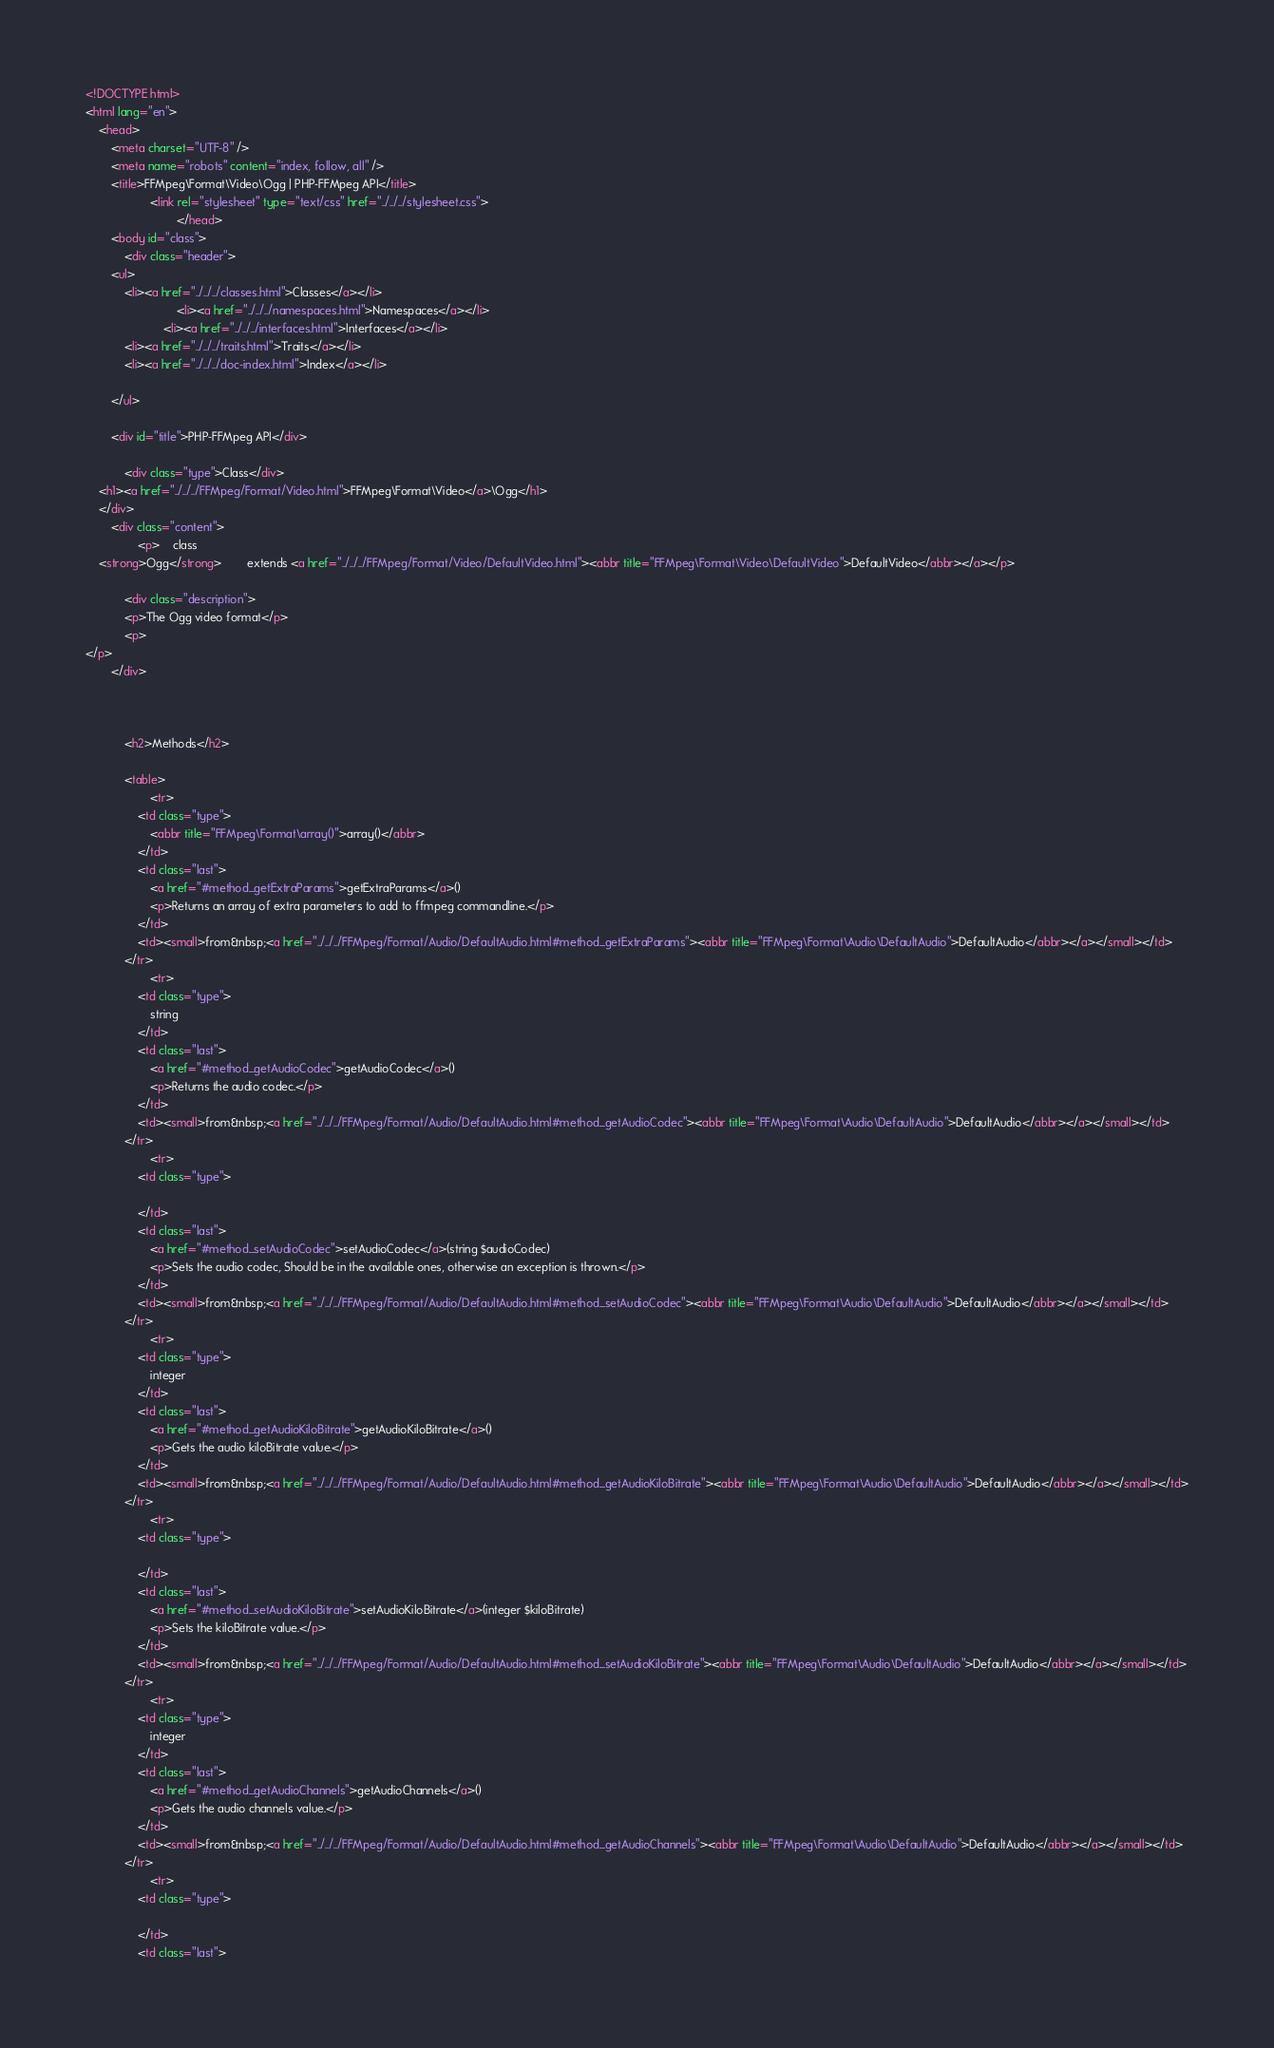Convert code to text. <code><loc_0><loc_0><loc_500><loc_500><_HTML_><!DOCTYPE html>
<html lang="en">
    <head>
        <meta charset="UTF-8" />
        <meta name="robots" content="index, follow, all" />
        <title>FFMpeg\Format\Video\Ogg | PHP-FFMpeg API</title>
                    <link rel="stylesheet" type="text/css" href="../../../stylesheet.css">
                            </head>
        <body id="class">
            <div class="header">
        <ul>
            <li><a href="../../../classes.html">Classes</a></li>
                            <li><a href="../../../namespaces.html">Namespaces</a></li>
                        <li><a href="../../../interfaces.html">Interfaces</a></li>
            <li><a href="../../../traits.html">Traits</a></li>
            <li><a href="../../../doc-index.html">Index</a></li>
            
        </ul>

        <div id="title">PHP-FFMpeg API</div>

            <div class="type">Class</div>
    <h1><a href="../../../FFMpeg/Format/Video.html">FFMpeg\Format\Video</a>\Ogg</h1>
    </div>
        <div class="content">
                <p>    class
    <strong>Ogg</strong>        extends <a href="../../../FFMpeg/Format/Video/DefaultVideo.html"><abbr title="FFMpeg\Format\Video\DefaultVideo">DefaultVideo</abbr></a></p>

            <div class="description">
            <p>The Ogg video format</p>
            <p>
</p>
        </div>
    
    
    
            <h2>Methods</h2>

            <table>
                    <tr>
                <td class="type">
                    <abbr title="FFMpeg\Format\array()">array()</abbr>
                </td>
                <td class="last">
                    <a href="#method_getExtraParams">getExtraParams</a>()
                    <p>Returns an array of extra parameters to add to ffmpeg commandline.</p>
                </td>
                <td><small>from&nbsp;<a href="../../../FFMpeg/Format/Audio/DefaultAudio.html#method_getExtraParams"><abbr title="FFMpeg\Format\Audio\DefaultAudio">DefaultAudio</abbr></a></small></td>
            </tr>
                    <tr>
                <td class="type">
                    string
                </td>
                <td class="last">
                    <a href="#method_getAudioCodec">getAudioCodec</a>()
                    <p>Returns the audio codec.</p>
                </td>
                <td><small>from&nbsp;<a href="../../../FFMpeg/Format/Audio/DefaultAudio.html#method_getAudioCodec"><abbr title="FFMpeg\Format\Audio\DefaultAudio">DefaultAudio</abbr></a></small></td>
            </tr>
                    <tr>
                <td class="type">
                    
                </td>
                <td class="last">
                    <a href="#method_setAudioCodec">setAudioCodec</a>(string $audioCodec)
                    <p>Sets the audio codec, Should be in the available ones, otherwise an exception is thrown.</p>
                </td>
                <td><small>from&nbsp;<a href="../../../FFMpeg/Format/Audio/DefaultAudio.html#method_setAudioCodec"><abbr title="FFMpeg\Format\Audio\DefaultAudio">DefaultAudio</abbr></a></small></td>
            </tr>
                    <tr>
                <td class="type">
                    integer
                </td>
                <td class="last">
                    <a href="#method_getAudioKiloBitrate">getAudioKiloBitrate</a>()
                    <p>Gets the audio kiloBitrate value.</p>
                </td>
                <td><small>from&nbsp;<a href="../../../FFMpeg/Format/Audio/DefaultAudio.html#method_getAudioKiloBitrate"><abbr title="FFMpeg\Format\Audio\DefaultAudio">DefaultAudio</abbr></a></small></td>
            </tr>
                    <tr>
                <td class="type">
                    
                </td>
                <td class="last">
                    <a href="#method_setAudioKiloBitrate">setAudioKiloBitrate</a>(integer $kiloBitrate)
                    <p>Sets the kiloBitrate value.</p>
                </td>
                <td><small>from&nbsp;<a href="../../../FFMpeg/Format/Audio/DefaultAudio.html#method_setAudioKiloBitrate"><abbr title="FFMpeg\Format\Audio\DefaultAudio">DefaultAudio</abbr></a></small></td>
            </tr>
                    <tr>
                <td class="type">
                    integer
                </td>
                <td class="last">
                    <a href="#method_getAudioChannels">getAudioChannels</a>()
                    <p>Gets the audio channels value.</p>
                </td>
                <td><small>from&nbsp;<a href="../../../FFMpeg/Format/Audio/DefaultAudio.html#method_getAudioChannels"><abbr title="FFMpeg\Format\Audio\DefaultAudio">DefaultAudio</abbr></a></small></td>
            </tr>
                    <tr>
                <td class="type">
                    
                </td>
                <td class="last"></code> 